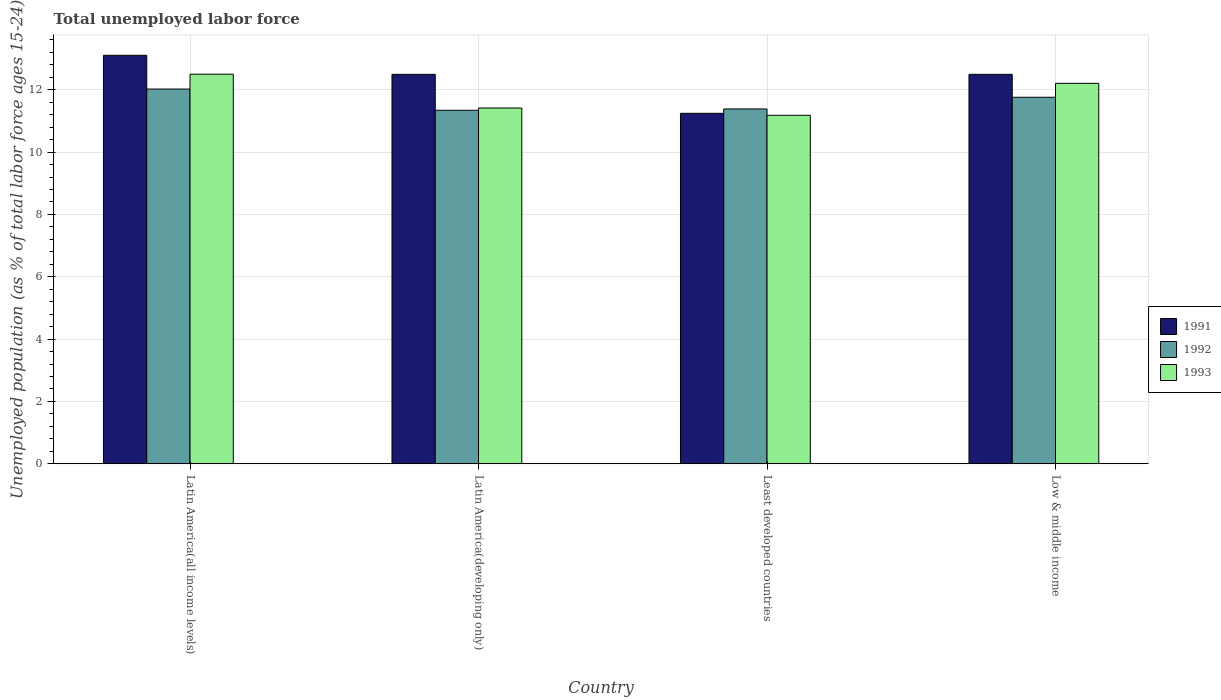How many different coloured bars are there?
Your answer should be very brief. 3. Are the number of bars on each tick of the X-axis equal?
Your answer should be very brief. Yes. What is the label of the 1st group of bars from the left?
Offer a terse response. Latin America(all income levels). What is the percentage of unemployed population in in 1992 in Low & middle income?
Your response must be concise. 11.76. Across all countries, what is the maximum percentage of unemployed population in in 1993?
Ensure brevity in your answer.  12.5. Across all countries, what is the minimum percentage of unemployed population in in 1993?
Provide a succinct answer. 11.18. In which country was the percentage of unemployed population in in 1991 maximum?
Offer a very short reply. Latin America(all income levels). In which country was the percentage of unemployed population in in 1991 minimum?
Ensure brevity in your answer.  Least developed countries. What is the total percentage of unemployed population in in 1991 in the graph?
Your answer should be very brief. 49.34. What is the difference between the percentage of unemployed population in in 1991 in Latin America(all income levels) and that in Latin America(developing only)?
Your answer should be very brief. 0.61. What is the difference between the percentage of unemployed population in in 1993 in Latin America(all income levels) and the percentage of unemployed population in in 1991 in Latin America(developing only)?
Ensure brevity in your answer.  0.01. What is the average percentage of unemployed population in in 1992 per country?
Offer a very short reply. 11.63. What is the difference between the percentage of unemployed population in of/in 1992 and percentage of unemployed population in of/in 1991 in Least developed countries?
Your answer should be very brief. 0.14. In how many countries, is the percentage of unemployed population in in 1992 greater than 12.8 %?
Keep it short and to the point. 0. What is the ratio of the percentage of unemployed population in in 1991 in Latin America(developing only) to that in Low & middle income?
Ensure brevity in your answer.  1. What is the difference between the highest and the second highest percentage of unemployed population in in 1991?
Make the answer very short. -0. What is the difference between the highest and the lowest percentage of unemployed population in in 1993?
Your answer should be very brief. 1.32. In how many countries, is the percentage of unemployed population in in 1991 greater than the average percentage of unemployed population in in 1991 taken over all countries?
Provide a succinct answer. 3. Is the sum of the percentage of unemployed population in in 1992 in Least developed countries and Low & middle income greater than the maximum percentage of unemployed population in in 1991 across all countries?
Keep it short and to the point. Yes. Is it the case that in every country, the sum of the percentage of unemployed population in in 1993 and percentage of unemployed population in in 1992 is greater than the percentage of unemployed population in in 1991?
Offer a very short reply. Yes. Are the values on the major ticks of Y-axis written in scientific E-notation?
Make the answer very short. No. Where does the legend appear in the graph?
Your answer should be compact. Center right. What is the title of the graph?
Give a very brief answer. Total unemployed labor force. What is the label or title of the Y-axis?
Your response must be concise. Unemployed population (as % of total labor force ages 15-24). What is the Unemployed population (as % of total labor force ages 15-24) of 1991 in Latin America(all income levels)?
Keep it short and to the point. 13.11. What is the Unemployed population (as % of total labor force ages 15-24) in 1992 in Latin America(all income levels)?
Give a very brief answer. 12.02. What is the Unemployed population (as % of total labor force ages 15-24) in 1993 in Latin America(all income levels)?
Offer a terse response. 12.5. What is the Unemployed population (as % of total labor force ages 15-24) of 1991 in Latin America(developing only)?
Your answer should be very brief. 12.5. What is the Unemployed population (as % of total labor force ages 15-24) in 1992 in Latin America(developing only)?
Provide a short and direct response. 11.34. What is the Unemployed population (as % of total labor force ages 15-24) in 1993 in Latin America(developing only)?
Keep it short and to the point. 11.42. What is the Unemployed population (as % of total labor force ages 15-24) in 1991 in Least developed countries?
Make the answer very short. 11.25. What is the Unemployed population (as % of total labor force ages 15-24) in 1992 in Least developed countries?
Give a very brief answer. 11.39. What is the Unemployed population (as % of total labor force ages 15-24) in 1993 in Least developed countries?
Keep it short and to the point. 11.18. What is the Unemployed population (as % of total labor force ages 15-24) of 1991 in Low & middle income?
Make the answer very short. 12.5. What is the Unemployed population (as % of total labor force ages 15-24) of 1992 in Low & middle income?
Offer a terse response. 11.76. What is the Unemployed population (as % of total labor force ages 15-24) of 1993 in Low & middle income?
Offer a terse response. 12.21. Across all countries, what is the maximum Unemployed population (as % of total labor force ages 15-24) of 1991?
Make the answer very short. 13.11. Across all countries, what is the maximum Unemployed population (as % of total labor force ages 15-24) of 1992?
Your answer should be very brief. 12.02. Across all countries, what is the maximum Unemployed population (as % of total labor force ages 15-24) in 1993?
Keep it short and to the point. 12.5. Across all countries, what is the minimum Unemployed population (as % of total labor force ages 15-24) of 1991?
Your answer should be compact. 11.25. Across all countries, what is the minimum Unemployed population (as % of total labor force ages 15-24) in 1992?
Your response must be concise. 11.34. Across all countries, what is the minimum Unemployed population (as % of total labor force ages 15-24) in 1993?
Ensure brevity in your answer.  11.18. What is the total Unemployed population (as % of total labor force ages 15-24) in 1991 in the graph?
Make the answer very short. 49.34. What is the total Unemployed population (as % of total labor force ages 15-24) of 1992 in the graph?
Provide a succinct answer. 46.51. What is the total Unemployed population (as % of total labor force ages 15-24) in 1993 in the graph?
Your answer should be compact. 47.31. What is the difference between the Unemployed population (as % of total labor force ages 15-24) of 1991 in Latin America(all income levels) and that in Latin America(developing only)?
Your answer should be very brief. 0.61. What is the difference between the Unemployed population (as % of total labor force ages 15-24) of 1992 in Latin America(all income levels) and that in Latin America(developing only)?
Your response must be concise. 0.68. What is the difference between the Unemployed population (as % of total labor force ages 15-24) of 1993 in Latin America(all income levels) and that in Latin America(developing only)?
Offer a very short reply. 1.09. What is the difference between the Unemployed population (as % of total labor force ages 15-24) of 1991 in Latin America(all income levels) and that in Least developed countries?
Make the answer very short. 1.86. What is the difference between the Unemployed population (as % of total labor force ages 15-24) in 1992 in Latin America(all income levels) and that in Least developed countries?
Provide a succinct answer. 0.64. What is the difference between the Unemployed population (as % of total labor force ages 15-24) in 1993 in Latin America(all income levels) and that in Least developed countries?
Your answer should be compact. 1.32. What is the difference between the Unemployed population (as % of total labor force ages 15-24) of 1991 in Latin America(all income levels) and that in Low & middle income?
Make the answer very short. 0.61. What is the difference between the Unemployed population (as % of total labor force ages 15-24) in 1992 in Latin America(all income levels) and that in Low & middle income?
Make the answer very short. 0.26. What is the difference between the Unemployed population (as % of total labor force ages 15-24) of 1993 in Latin America(all income levels) and that in Low & middle income?
Your response must be concise. 0.29. What is the difference between the Unemployed population (as % of total labor force ages 15-24) of 1991 in Latin America(developing only) and that in Least developed countries?
Offer a very short reply. 1.25. What is the difference between the Unemployed population (as % of total labor force ages 15-24) in 1992 in Latin America(developing only) and that in Least developed countries?
Keep it short and to the point. -0.04. What is the difference between the Unemployed population (as % of total labor force ages 15-24) in 1993 in Latin America(developing only) and that in Least developed countries?
Provide a short and direct response. 0.23. What is the difference between the Unemployed population (as % of total labor force ages 15-24) in 1991 in Latin America(developing only) and that in Low & middle income?
Provide a short and direct response. -0. What is the difference between the Unemployed population (as % of total labor force ages 15-24) of 1992 in Latin America(developing only) and that in Low & middle income?
Provide a succinct answer. -0.42. What is the difference between the Unemployed population (as % of total labor force ages 15-24) in 1993 in Latin America(developing only) and that in Low & middle income?
Your answer should be very brief. -0.79. What is the difference between the Unemployed population (as % of total labor force ages 15-24) in 1991 in Least developed countries and that in Low & middle income?
Offer a terse response. -1.25. What is the difference between the Unemployed population (as % of total labor force ages 15-24) of 1992 in Least developed countries and that in Low & middle income?
Provide a succinct answer. -0.37. What is the difference between the Unemployed population (as % of total labor force ages 15-24) of 1993 in Least developed countries and that in Low & middle income?
Provide a short and direct response. -1.03. What is the difference between the Unemployed population (as % of total labor force ages 15-24) of 1991 in Latin America(all income levels) and the Unemployed population (as % of total labor force ages 15-24) of 1992 in Latin America(developing only)?
Offer a terse response. 1.76. What is the difference between the Unemployed population (as % of total labor force ages 15-24) in 1991 in Latin America(all income levels) and the Unemployed population (as % of total labor force ages 15-24) in 1993 in Latin America(developing only)?
Your answer should be very brief. 1.69. What is the difference between the Unemployed population (as % of total labor force ages 15-24) of 1992 in Latin America(all income levels) and the Unemployed population (as % of total labor force ages 15-24) of 1993 in Latin America(developing only)?
Your answer should be very brief. 0.61. What is the difference between the Unemployed population (as % of total labor force ages 15-24) of 1991 in Latin America(all income levels) and the Unemployed population (as % of total labor force ages 15-24) of 1992 in Least developed countries?
Offer a terse response. 1.72. What is the difference between the Unemployed population (as % of total labor force ages 15-24) in 1991 in Latin America(all income levels) and the Unemployed population (as % of total labor force ages 15-24) in 1993 in Least developed countries?
Offer a very short reply. 1.93. What is the difference between the Unemployed population (as % of total labor force ages 15-24) in 1992 in Latin America(all income levels) and the Unemployed population (as % of total labor force ages 15-24) in 1993 in Least developed countries?
Offer a very short reply. 0.84. What is the difference between the Unemployed population (as % of total labor force ages 15-24) in 1991 in Latin America(all income levels) and the Unemployed population (as % of total labor force ages 15-24) in 1992 in Low & middle income?
Ensure brevity in your answer.  1.35. What is the difference between the Unemployed population (as % of total labor force ages 15-24) in 1991 in Latin America(all income levels) and the Unemployed population (as % of total labor force ages 15-24) in 1993 in Low & middle income?
Make the answer very short. 0.9. What is the difference between the Unemployed population (as % of total labor force ages 15-24) of 1992 in Latin America(all income levels) and the Unemployed population (as % of total labor force ages 15-24) of 1993 in Low & middle income?
Keep it short and to the point. -0.18. What is the difference between the Unemployed population (as % of total labor force ages 15-24) of 1991 in Latin America(developing only) and the Unemployed population (as % of total labor force ages 15-24) of 1992 in Least developed countries?
Offer a very short reply. 1.11. What is the difference between the Unemployed population (as % of total labor force ages 15-24) in 1991 in Latin America(developing only) and the Unemployed population (as % of total labor force ages 15-24) in 1993 in Least developed countries?
Make the answer very short. 1.31. What is the difference between the Unemployed population (as % of total labor force ages 15-24) in 1992 in Latin America(developing only) and the Unemployed population (as % of total labor force ages 15-24) in 1993 in Least developed countries?
Your answer should be compact. 0.16. What is the difference between the Unemployed population (as % of total labor force ages 15-24) in 1991 in Latin America(developing only) and the Unemployed population (as % of total labor force ages 15-24) in 1992 in Low & middle income?
Make the answer very short. 0.74. What is the difference between the Unemployed population (as % of total labor force ages 15-24) of 1991 in Latin America(developing only) and the Unemployed population (as % of total labor force ages 15-24) of 1993 in Low & middle income?
Your response must be concise. 0.29. What is the difference between the Unemployed population (as % of total labor force ages 15-24) in 1992 in Latin America(developing only) and the Unemployed population (as % of total labor force ages 15-24) in 1993 in Low & middle income?
Give a very brief answer. -0.86. What is the difference between the Unemployed population (as % of total labor force ages 15-24) in 1991 in Least developed countries and the Unemployed population (as % of total labor force ages 15-24) in 1992 in Low & middle income?
Your answer should be very brief. -0.51. What is the difference between the Unemployed population (as % of total labor force ages 15-24) of 1991 in Least developed countries and the Unemployed population (as % of total labor force ages 15-24) of 1993 in Low & middle income?
Make the answer very short. -0.96. What is the difference between the Unemployed population (as % of total labor force ages 15-24) of 1992 in Least developed countries and the Unemployed population (as % of total labor force ages 15-24) of 1993 in Low & middle income?
Provide a short and direct response. -0.82. What is the average Unemployed population (as % of total labor force ages 15-24) of 1991 per country?
Provide a short and direct response. 12.34. What is the average Unemployed population (as % of total labor force ages 15-24) of 1992 per country?
Offer a terse response. 11.63. What is the average Unemployed population (as % of total labor force ages 15-24) of 1993 per country?
Your answer should be very brief. 11.83. What is the difference between the Unemployed population (as % of total labor force ages 15-24) of 1991 and Unemployed population (as % of total labor force ages 15-24) of 1992 in Latin America(all income levels)?
Your answer should be very brief. 1.08. What is the difference between the Unemployed population (as % of total labor force ages 15-24) in 1991 and Unemployed population (as % of total labor force ages 15-24) in 1993 in Latin America(all income levels)?
Offer a very short reply. 0.61. What is the difference between the Unemployed population (as % of total labor force ages 15-24) of 1992 and Unemployed population (as % of total labor force ages 15-24) of 1993 in Latin America(all income levels)?
Keep it short and to the point. -0.48. What is the difference between the Unemployed population (as % of total labor force ages 15-24) of 1991 and Unemployed population (as % of total labor force ages 15-24) of 1992 in Latin America(developing only)?
Your answer should be compact. 1.15. What is the difference between the Unemployed population (as % of total labor force ages 15-24) of 1991 and Unemployed population (as % of total labor force ages 15-24) of 1993 in Latin America(developing only)?
Your answer should be compact. 1.08. What is the difference between the Unemployed population (as % of total labor force ages 15-24) in 1992 and Unemployed population (as % of total labor force ages 15-24) in 1993 in Latin America(developing only)?
Ensure brevity in your answer.  -0.07. What is the difference between the Unemployed population (as % of total labor force ages 15-24) in 1991 and Unemployed population (as % of total labor force ages 15-24) in 1992 in Least developed countries?
Ensure brevity in your answer.  -0.14. What is the difference between the Unemployed population (as % of total labor force ages 15-24) of 1991 and Unemployed population (as % of total labor force ages 15-24) of 1993 in Least developed countries?
Give a very brief answer. 0.06. What is the difference between the Unemployed population (as % of total labor force ages 15-24) of 1992 and Unemployed population (as % of total labor force ages 15-24) of 1993 in Least developed countries?
Your response must be concise. 0.2. What is the difference between the Unemployed population (as % of total labor force ages 15-24) in 1991 and Unemployed population (as % of total labor force ages 15-24) in 1992 in Low & middle income?
Make the answer very short. 0.74. What is the difference between the Unemployed population (as % of total labor force ages 15-24) of 1991 and Unemployed population (as % of total labor force ages 15-24) of 1993 in Low & middle income?
Your answer should be very brief. 0.29. What is the difference between the Unemployed population (as % of total labor force ages 15-24) of 1992 and Unemployed population (as % of total labor force ages 15-24) of 1993 in Low & middle income?
Your answer should be very brief. -0.45. What is the ratio of the Unemployed population (as % of total labor force ages 15-24) in 1991 in Latin America(all income levels) to that in Latin America(developing only)?
Your answer should be very brief. 1.05. What is the ratio of the Unemployed population (as % of total labor force ages 15-24) in 1992 in Latin America(all income levels) to that in Latin America(developing only)?
Offer a very short reply. 1.06. What is the ratio of the Unemployed population (as % of total labor force ages 15-24) of 1993 in Latin America(all income levels) to that in Latin America(developing only)?
Provide a succinct answer. 1.1. What is the ratio of the Unemployed population (as % of total labor force ages 15-24) of 1991 in Latin America(all income levels) to that in Least developed countries?
Ensure brevity in your answer.  1.17. What is the ratio of the Unemployed population (as % of total labor force ages 15-24) of 1992 in Latin America(all income levels) to that in Least developed countries?
Your answer should be very brief. 1.06. What is the ratio of the Unemployed population (as % of total labor force ages 15-24) in 1993 in Latin America(all income levels) to that in Least developed countries?
Ensure brevity in your answer.  1.12. What is the ratio of the Unemployed population (as % of total labor force ages 15-24) of 1991 in Latin America(all income levels) to that in Low & middle income?
Your answer should be compact. 1.05. What is the ratio of the Unemployed population (as % of total labor force ages 15-24) in 1992 in Latin America(all income levels) to that in Low & middle income?
Offer a terse response. 1.02. What is the ratio of the Unemployed population (as % of total labor force ages 15-24) of 1993 in Latin America(all income levels) to that in Low & middle income?
Provide a short and direct response. 1.02. What is the ratio of the Unemployed population (as % of total labor force ages 15-24) of 1991 in Latin America(developing only) to that in Least developed countries?
Keep it short and to the point. 1.11. What is the ratio of the Unemployed population (as % of total labor force ages 15-24) of 1993 in Latin America(developing only) to that in Least developed countries?
Offer a terse response. 1.02. What is the ratio of the Unemployed population (as % of total labor force ages 15-24) in 1991 in Latin America(developing only) to that in Low & middle income?
Ensure brevity in your answer.  1. What is the ratio of the Unemployed population (as % of total labor force ages 15-24) of 1992 in Latin America(developing only) to that in Low & middle income?
Your response must be concise. 0.96. What is the ratio of the Unemployed population (as % of total labor force ages 15-24) of 1993 in Latin America(developing only) to that in Low & middle income?
Your answer should be compact. 0.94. What is the ratio of the Unemployed population (as % of total labor force ages 15-24) of 1991 in Least developed countries to that in Low & middle income?
Ensure brevity in your answer.  0.9. What is the ratio of the Unemployed population (as % of total labor force ages 15-24) in 1992 in Least developed countries to that in Low & middle income?
Make the answer very short. 0.97. What is the ratio of the Unemployed population (as % of total labor force ages 15-24) of 1993 in Least developed countries to that in Low & middle income?
Provide a short and direct response. 0.92. What is the difference between the highest and the second highest Unemployed population (as % of total labor force ages 15-24) of 1991?
Your answer should be very brief. 0.61. What is the difference between the highest and the second highest Unemployed population (as % of total labor force ages 15-24) of 1992?
Your answer should be very brief. 0.26. What is the difference between the highest and the second highest Unemployed population (as % of total labor force ages 15-24) of 1993?
Provide a short and direct response. 0.29. What is the difference between the highest and the lowest Unemployed population (as % of total labor force ages 15-24) of 1991?
Offer a terse response. 1.86. What is the difference between the highest and the lowest Unemployed population (as % of total labor force ages 15-24) of 1992?
Your answer should be very brief. 0.68. What is the difference between the highest and the lowest Unemployed population (as % of total labor force ages 15-24) in 1993?
Give a very brief answer. 1.32. 